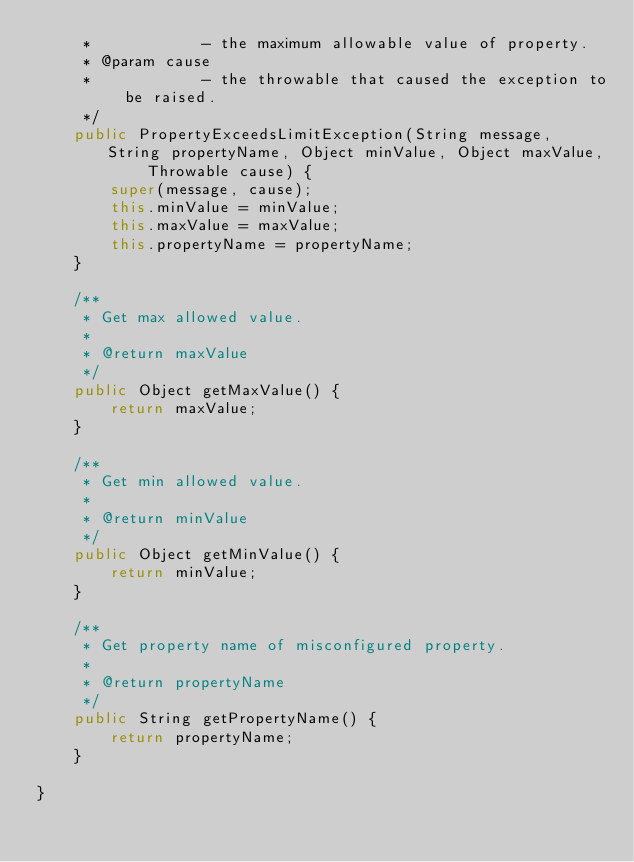Convert code to text. <code><loc_0><loc_0><loc_500><loc_500><_Java_>	 *            - the maximum allowable value of property.
	 * @param cause
	 *            - the throwable that caused the exception to be raised.
	 */
	public PropertyExceedsLimitException(String message, String propertyName, Object minValue, Object maxValue, 
			Throwable cause) {
		super(message, cause);
		this.minValue = minValue;
		this.maxValue = maxValue;
		this.propertyName = propertyName;
	}

	/**
	 * Get max allowed value.
	 * 
	 * @return maxValue
	 */
	public Object getMaxValue() {
		return maxValue;
	}

	/**
	 * Get min allowed value.
	 * 
	 * @return minValue
	 */
	public Object getMinValue() {
		return minValue;
	}

	/**
	 * Get property name of misconfigured property.
	 * 
	 * @return propertyName
	 */
	public String getPropertyName() {
		return propertyName;
	}

}</code> 